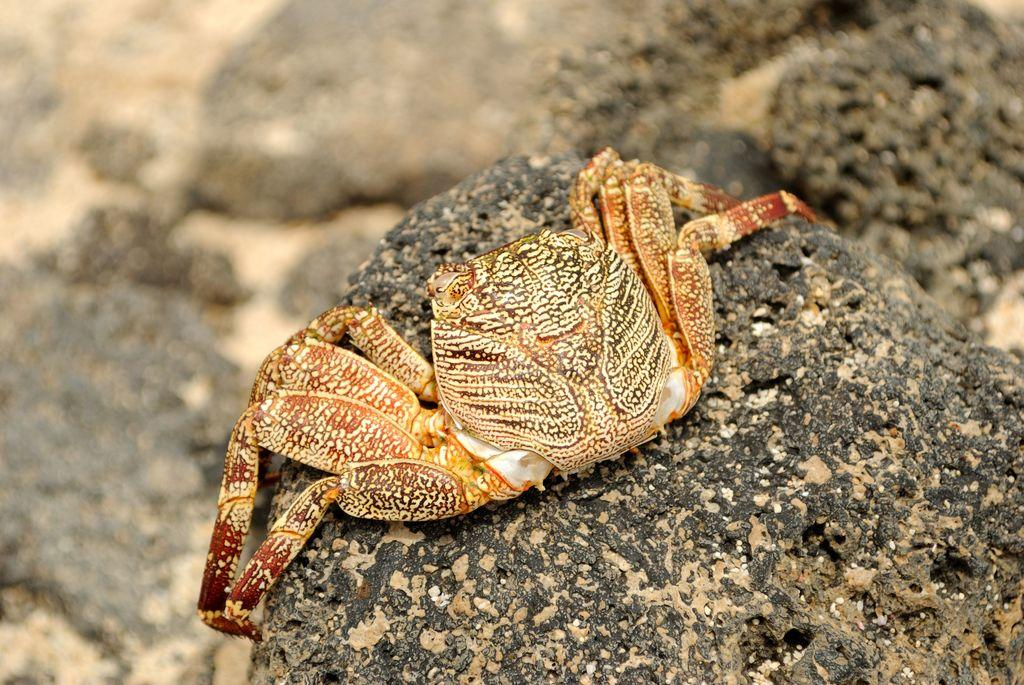What is the main subject of the image? There is a crab in the image. Where is the crab located? The crab is on a stone. Can you describe the background of the image? The background of the image is blurred. What type of locket is the crab holding in the image? There is no locket present in the image; the crab is simply on a stone. 